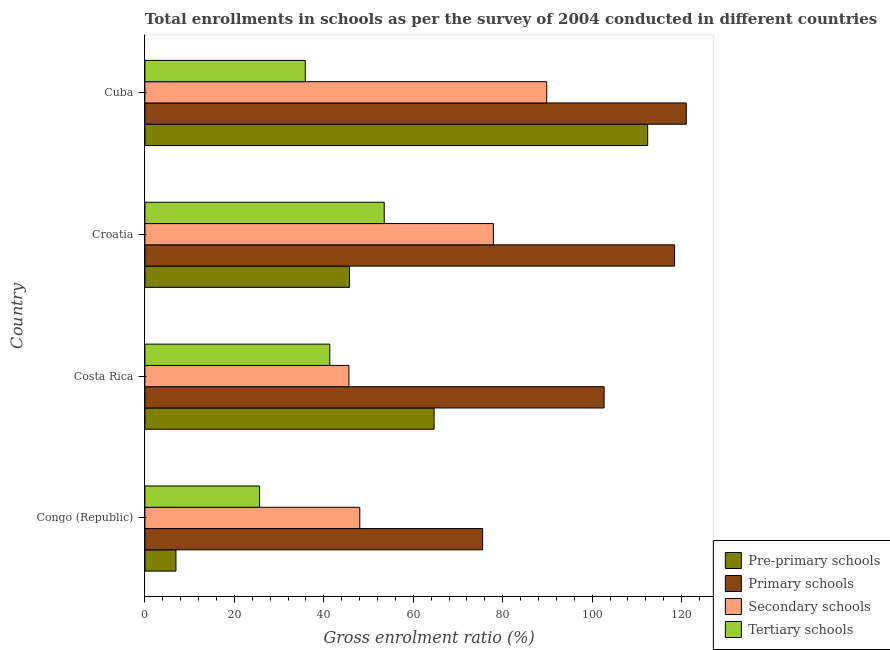Are the number of bars per tick equal to the number of legend labels?
Give a very brief answer. Yes. Are the number of bars on each tick of the Y-axis equal?
Your answer should be very brief. Yes. In how many cases, is the number of bars for a given country not equal to the number of legend labels?
Offer a very short reply. 0. What is the gross enrolment ratio in pre-primary schools in Cuba?
Ensure brevity in your answer.  112.42. Across all countries, what is the maximum gross enrolment ratio in tertiary schools?
Your response must be concise. 53.51. Across all countries, what is the minimum gross enrolment ratio in secondary schools?
Provide a short and direct response. 45.62. In which country was the gross enrolment ratio in tertiary schools maximum?
Ensure brevity in your answer.  Croatia. In which country was the gross enrolment ratio in secondary schools minimum?
Give a very brief answer. Costa Rica. What is the total gross enrolment ratio in tertiary schools in the graph?
Provide a succinct answer. 156.36. What is the difference between the gross enrolment ratio in primary schools in Costa Rica and that in Cuba?
Provide a short and direct response. -18.38. What is the difference between the gross enrolment ratio in pre-primary schools in Croatia and the gross enrolment ratio in primary schools in Cuba?
Give a very brief answer. -75.3. What is the average gross enrolment ratio in primary schools per country?
Your answer should be very brief. 104.42. What is the difference between the gross enrolment ratio in pre-primary schools and gross enrolment ratio in tertiary schools in Congo (Republic)?
Your answer should be compact. -18.7. In how many countries, is the gross enrolment ratio in pre-primary schools greater than 112 %?
Your response must be concise. 1. What is the ratio of the gross enrolment ratio in pre-primary schools in Costa Rica to that in Cuba?
Offer a terse response. 0.57. What is the difference between the highest and the second highest gross enrolment ratio in pre-primary schools?
Provide a succinct answer. 47.75. What is the difference between the highest and the lowest gross enrolment ratio in secondary schools?
Give a very brief answer. 44.23. What does the 4th bar from the top in Cuba represents?
Give a very brief answer. Pre-primary schools. What does the 2nd bar from the bottom in Cuba represents?
Make the answer very short. Primary schools. Is it the case that in every country, the sum of the gross enrolment ratio in pre-primary schools and gross enrolment ratio in primary schools is greater than the gross enrolment ratio in secondary schools?
Offer a terse response. Yes. How many bars are there?
Provide a succinct answer. 16. How many countries are there in the graph?
Provide a succinct answer. 4. Are the values on the major ticks of X-axis written in scientific E-notation?
Make the answer very short. No. Does the graph contain any zero values?
Give a very brief answer. No. Where does the legend appear in the graph?
Provide a succinct answer. Bottom right. How are the legend labels stacked?
Keep it short and to the point. Vertical. What is the title of the graph?
Keep it short and to the point. Total enrollments in schools as per the survey of 2004 conducted in different countries. What is the label or title of the X-axis?
Your response must be concise. Gross enrolment ratio (%). What is the label or title of the Y-axis?
Make the answer very short. Country. What is the Gross enrolment ratio (%) of Pre-primary schools in Congo (Republic)?
Provide a succinct answer. 6.94. What is the Gross enrolment ratio (%) of Primary schools in Congo (Republic)?
Your response must be concise. 75.51. What is the Gross enrolment ratio (%) in Secondary schools in Congo (Republic)?
Your answer should be compact. 48.05. What is the Gross enrolment ratio (%) in Tertiary schools in Congo (Republic)?
Keep it short and to the point. 25.64. What is the Gross enrolment ratio (%) in Pre-primary schools in Costa Rica?
Give a very brief answer. 64.67. What is the Gross enrolment ratio (%) of Primary schools in Costa Rica?
Give a very brief answer. 102.68. What is the Gross enrolment ratio (%) of Secondary schools in Costa Rica?
Provide a succinct answer. 45.62. What is the Gross enrolment ratio (%) of Tertiary schools in Costa Rica?
Offer a very short reply. 41.35. What is the Gross enrolment ratio (%) of Pre-primary schools in Croatia?
Make the answer very short. 45.76. What is the Gross enrolment ratio (%) of Primary schools in Croatia?
Keep it short and to the point. 118.44. What is the Gross enrolment ratio (%) in Secondary schools in Croatia?
Provide a succinct answer. 77.91. What is the Gross enrolment ratio (%) in Tertiary schools in Croatia?
Offer a very short reply. 53.51. What is the Gross enrolment ratio (%) of Pre-primary schools in Cuba?
Make the answer very short. 112.42. What is the Gross enrolment ratio (%) in Primary schools in Cuba?
Ensure brevity in your answer.  121.06. What is the Gross enrolment ratio (%) in Secondary schools in Cuba?
Provide a short and direct response. 89.85. What is the Gross enrolment ratio (%) in Tertiary schools in Cuba?
Give a very brief answer. 35.86. Across all countries, what is the maximum Gross enrolment ratio (%) of Pre-primary schools?
Provide a short and direct response. 112.42. Across all countries, what is the maximum Gross enrolment ratio (%) of Primary schools?
Offer a terse response. 121.06. Across all countries, what is the maximum Gross enrolment ratio (%) of Secondary schools?
Ensure brevity in your answer.  89.85. Across all countries, what is the maximum Gross enrolment ratio (%) in Tertiary schools?
Offer a terse response. 53.51. Across all countries, what is the minimum Gross enrolment ratio (%) of Pre-primary schools?
Offer a terse response. 6.94. Across all countries, what is the minimum Gross enrolment ratio (%) in Primary schools?
Ensure brevity in your answer.  75.51. Across all countries, what is the minimum Gross enrolment ratio (%) in Secondary schools?
Keep it short and to the point. 45.62. Across all countries, what is the minimum Gross enrolment ratio (%) in Tertiary schools?
Your answer should be very brief. 25.64. What is the total Gross enrolment ratio (%) of Pre-primary schools in the graph?
Provide a succinct answer. 229.78. What is the total Gross enrolment ratio (%) of Primary schools in the graph?
Ensure brevity in your answer.  417.69. What is the total Gross enrolment ratio (%) of Secondary schools in the graph?
Your answer should be compact. 261.42. What is the total Gross enrolment ratio (%) in Tertiary schools in the graph?
Your response must be concise. 156.36. What is the difference between the Gross enrolment ratio (%) in Pre-primary schools in Congo (Republic) and that in Costa Rica?
Make the answer very short. -57.73. What is the difference between the Gross enrolment ratio (%) in Primary schools in Congo (Republic) and that in Costa Rica?
Your answer should be compact. -27.17. What is the difference between the Gross enrolment ratio (%) of Secondary schools in Congo (Republic) and that in Costa Rica?
Ensure brevity in your answer.  2.43. What is the difference between the Gross enrolment ratio (%) of Tertiary schools in Congo (Republic) and that in Costa Rica?
Provide a short and direct response. -15.71. What is the difference between the Gross enrolment ratio (%) of Pre-primary schools in Congo (Republic) and that in Croatia?
Your answer should be very brief. -38.82. What is the difference between the Gross enrolment ratio (%) of Primary schools in Congo (Republic) and that in Croatia?
Offer a very short reply. -42.92. What is the difference between the Gross enrolment ratio (%) in Secondary schools in Congo (Republic) and that in Croatia?
Give a very brief answer. -29.86. What is the difference between the Gross enrolment ratio (%) in Tertiary schools in Congo (Republic) and that in Croatia?
Provide a short and direct response. -27.87. What is the difference between the Gross enrolment ratio (%) of Pre-primary schools in Congo (Republic) and that in Cuba?
Give a very brief answer. -105.48. What is the difference between the Gross enrolment ratio (%) in Primary schools in Congo (Republic) and that in Cuba?
Your response must be concise. -45.54. What is the difference between the Gross enrolment ratio (%) in Secondary schools in Congo (Republic) and that in Cuba?
Your response must be concise. -41.8. What is the difference between the Gross enrolment ratio (%) in Tertiary schools in Congo (Republic) and that in Cuba?
Provide a succinct answer. -10.22. What is the difference between the Gross enrolment ratio (%) in Pre-primary schools in Costa Rica and that in Croatia?
Provide a short and direct response. 18.91. What is the difference between the Gross enrolment ratio (%) of Primary schools in Costa Rica and that in Croatia?
Offer a terse response. -15.76. What is the difference between the Gross enrolment ratio (%) of Secondary schools in Costa Rica and that in Croatia?
Keep it short and to the point. -32.3. What is the difference between the Gross enrolment ratio (%) of Tertiary schools in Costa Rica and that in Croatia?
Provide a succinct answer. -12.17. What is the difference between the Gross enrolment ratio (%) in Pre-primary schools in Costa Rica and that in Cuba?
Your answer should be very brief. -47.75. What is the difference between the Gross enrolment ratio (%) of Primary schools in Costa Rica and that in Cuba?
Make the answer very short. -18.38. What is the difference between the Gross enrolment ratio (%) of Secondary schools in Costa Rica and that in Cuba?
Your answer should be very brief. -44.23. What is the difference between the Gross enrolment ratio (%) in Tertiary schools in Costa Rica and that in Cuba?
Your answer should be very brief. 5.48. What is the difference between the Gross enrolment ratio (%) in Pre-primary schools in Croatia and that in Cuba?
Give a very brief answer. -66.66. What is the difference between the Gross enrolment ratio (%) of Primary schools in Croatia and that in Cuba?
Offer a very short reply. -2.62. What is the difference between the Gross enrolment ratio (%) of Secondary schools in Croatia and that in Cuba?
Make the answer very short. -11.94. What is the difference between the Gross enrolment ratio (%) in Tertiary schools in Croatia and that in Cuba?
Your answer should be very brief. 17.65. What is the difference between the Gross enrolment ratio (%) of Pre-primary schools in Congo (Republic) and the Gross enrolment ratio (%) of Primary schools in Costa Rica?
Ensure brevity in your answer.  -95.74. What is the difference between the Gross enrolment ratio (%) in Pre-primary schools in Congo (Republic) and the Gross enrolment ratio (%) in Secondary schools in Costa Rica?
Make the answer very short. -38.68. What is the difference between the Gross enrolment ratio (%) of Pre-primary schools in Congo (Republic) and the Gross enrolment ratio (%) of Tertiary schools in Costa Rica?
Keep it short and to the point. -34.41. What is the difference between the Gross enrolment ratio (%) in Primary schools in Congo (Republic) and the Gross enrolment ratio (%) in Secondary schools in Costa Rica?
Offer a terse response. 29.9. What is the difference between the Gross enrolment ratio (%) in Primary schools in Congo (Republic) and the Gross enrolment ratio (%) in Tertiary schools in Costa Rica?
Provide a succinct answer. 34.17. What is the difference between the Gross enrolment ratio (%) of Secondary schools in Congo (Republic) and the Gross enrolment ratio (%) of Tertiary schools in Costa Rica?
Offer a terse response. 6.7. What is the difference between the Gross enrolment ratio (%) of Pre-primary schools in Congo (Republic) and the Gross enrolment ratio (%) of Primary schools in Croatia?
Provide a succinct answer. -111.5. What is the difference between the Gross enrolment ratio (%) of Pre-primary schools in Congo (Republic) and the Gross enrolment ratio (%) of Secondary schools in Croatia?
Your answer should be compact. -70.97. What is the difference between the Gross enrolment ratio (%) in Pre-primary schools in Congo (Republic) and the Gross enrolment ratio (%) in Tertiary schools in Croatia?
Give a very brief answer. -46.57. What is the difference between the Gross enrolment ratio (%) of Primary schools in Congo (Republic) and the Gross enrolment ratio (%) of Secondary schools in Croatia?
Provide a short and direct response. -2.4. What is the difference between the Gross enrolment ratio (%) in Primary schools in Congo (Republic) and the Gross enrolment ratio (%) in Tertiary schools in Croatia?
Ensure brevity in your answer.  22. What is the difference between the Gross enrolment ratio (%) in Secondary schools in Congo (Republic) and the Gross enrolment ratio (%) in Tertiary schools in Croatia?
Offer a very short reply. -5.46. What is the difference between the Gross enrolment ratio (%) in Pre-primary schools in Congo (Republic) and the Gross enrolment ratio (%) in Primary schools in Cuba?
Make the answer very short. -114.12. What is the difference between the Gross enrolment ratio (%) of Pre-primary schools in Congo (Republic) and the Gross enrolment ratio (%) of Secondary schools in Cuba?
Keep it short and to the point. -82.91. What is the difference between the Gross enrolment ratio (%) in Pre-primary schools in Congo (Republic) and the Gross enrolment ratio (%) in Tertiary schools in Cuba?
Provide a succinct answer. -28.93. What is the difference between the Gross enrolment ratio (%) in Primary schools in Congo (Republic) and the Gross enrolment ratio (%) in Secondary schools in Cuba?
Offer a terse response. -14.33. What is the difference between the Gross enrolment ratio (%) in Primary schools in Congo (Republic) and the Gross enrolment ratio (%) in Tertiary schools in Cuba?
Your answer should be compact. 39.65. What is the difference between the Gross enrolment ratio (%) in Secondary schools in Congo (Republic) and the Gross enrolment ratio (%) in Tertiary schools in Cuba?
Keep it short and to the point. 12.18. What is the difference between the Gross enrolment ratio (%) in Pre-primary schools in Costa Rica and the Gross enrolment ratio (%) in Primary schools in Croatia?
Ensure brevity in your answer.  -53.77. What is the difference between the Gross enrolment ratio (%) in Pre-primary schools in Costa Rica and the Gross enrolment ratio (%) in Secondary schools in Croatia?
Ensure brevity in your answer.  -13.25. What is the difference between the Gross enrolment ratio (%) of Pre-primary schools in Costa Rica and the Gross enrolment ratio (%) of Tertiary schools in Croatia?
Offer a terse response. 11.15. What is the difference between the Gross enrolment ratio (%) in Primary schools in Costa Rica and the Gross enrolment ratio (%) in Secondary schools in Croatia?
Provide a short and direct response. 24.77. What is the difference between the Gross enrolment ratio (%) in Primary schools in Costa Rica and the Gross enrolment ratio (%) in Tertiary schools in Croatia?
Your answer should be very brief. 49.17. What is the difference between the Gross enrolment ratio (%) of Secondary schools in Costa Rica and the Gross enrolment ratio (%) of Tertiary schools in Croatia?
Give a very brief answer. -7.9. What is the difference between the Gross enrolment ratio (%) in Pre-primary schools in Costa Rica and the Gross enrolment ratio (%) in Primary schools in Cuba?
Provide a short and direct response. -56.39. What is the difference between the Gross enrolment ratio (%) of Pre-primary schools in Costa Rica and the Gross enrolment ratio (%) of Secondary schools in Cuba?
Provide a succinct answer. -25.18. What is the difference between the Gross enrolment ratio (%) of Pre-primary schools in Costa Rica and the Gross enrolment ratio (%) of Tertiary schools in Cuba?
Give a very brief answer. 28.8. What is the difference between the Gross enrolment ratio (%) in Primary schools in Costa Rica and the Gross enrolment ratio (%) in Secondary schools in Cuba?
Offer a terse response. 12.83. What is the difference between the Gross enrolment ratio (%) in Primary schools in Costa Rica and the Gross enrolment ratio (%) in Tertiary schools in Cuba?
Keep it short and to the point. 66.82. What is the difference between the Gross enrolment ratio (%) in Secondary schools in Costa Rica and the Gross enrolment ratio (%) in Tertiary schools in Cuba?
Provide a short and direct response. 9.75. What is the difference between the Gross enrolment ratio (%) in Pre-primary schools in Croatia and the Gross enrolment ratio (%) in Primary schools in Cuba?
Keep it short and to the point. -75.3. What is the difference between the Gross enrolment ratio (%) of Pre-primary schools in Croatia and the Gross enrolment ratio (%) of Secondary schools in Cuba?
Provide a short and direct response. -44.09. What is the difference between the Gross enrolment ratio (%) in Pre-primary schools in Croatia and the Gross enrolment ratio (%) in Tertiary schools in Cuba?
Offer a terse response. 9.9. What is the difference between the Gross enrolment ratio (%) in Primary schools in Croatia and the Gross enrolment ratio (%) in Secondary schools in Cuba?
Your answer should be compact. 28.59. What is the difference between the Gross enrolment ratio (%) in Primary schools in Croatia and the Gross enrolment ratio (%) in Tertiary schools in Cuba?
Keep it short and to the point. 82.57. What is the difference between the Gross enrolment ratio (%) of Secondary schools in Croatia and the Gross enrolment ratio (%) of Tertiary schools in Cuba?
Provide a succinct answer. 42.05. What is the average Gross enrolment ratio (%) of Pre-primary schools per country?
Provide a short and direct response. 57.45. What is the average Gross enrolment ratio (%) in Primary schools per country?
Provide a short and direct response. 104.42. What is the average Gross enrolment ratio (%) in Secondary schools per country?
Offer a very short reply. 65.36. What is the average Gross enrolment ratio (%) in Tertiary schools per country?
Ensure brevity in your answer.  39.09. What is the difference between the Gross enrolment ratio (%) in Pre-primary schools and Gross enrolment ratio (%) in Primary schools in Congo (Republic)?
Offer a terse response. -68.57. What is the difference between the Gross enrolment ratio (%) in Pre-primary schools and Gross enrolment ratio (%) in Secondary schools in Congo (Republic)?
Make the answer very short. -41.11. What is the difference between the Gross enrolment ratio (%) in Pre-primary schools and Gross enrolment ratio (%) in Tertiary schools in Congo (Republic)?
Offer a very short reply. -18.7. What is the difference between the Gross enrolment ratio (%) of Primary schools and Gross enrolment ratio (%) of Secondary schools in Congo (Republic)?
Provide a succinct answer. 27.47. What is the difference between the Gross enrolment ratio (%) in Primary schools and Gross enrolment ratio (%) in Tertiary schools in Congo (Republic)?
Your response must be concise. 49.87. What is the difference between the Gross enrolment ratio (%) in Secondary schools and Gross enrolment ratio (%) in Tertiary schools in Congo (Republic)?
Make the answer very short. 22.41. What is the difference between the Gross enrolment ratio (%) in Pre-primary schools and Gross enrolment ratio (%) in Primary schools in Costa Rica?
Provide a short and direct response. -38.01. What is the difference between the Gross enrolment ratio (%) of Pre-primary schools and Gross enrolment ratio (%) of Secondary schools in Costa Rica?
Offer a terse response. 19.05. What is the difference between the Gross enrolment ratio (%) in Pre-primary schools and Gross enrolment ratio (%) in Tertiary schools in Costa Rica?
Ensure brevity in your answer.  23.32. What is the difference between the Gross enrolment ratio (%) of Primary schools and Gross enrolment ratio (%) of Secondary schools in Costa Rica?
Provide a short and direct response. 57.06. What is the difference between the Gross enrolment ratio (%) of Primary schools and Gross enrolment ratio (%) of Tertiary schools in Costa Rica?
Provide a succinct answer. 61.33. What is the difference between the Gross enrolment ratio (%) in Secondary schools and Gross enrolment ratio (%) in Tertiary schools in Costa Rica?
Ensure brevity in your answer.  4.27. What is the difference between the Gross enrolment ratio (%) of Pre-primary schools and Gross enrolment ratio (%) of Primary schools in Croatia?
Make the answer very short. -72.68. What is the difference between the Gross enrolment ratio (%) of Pre-primary schools and Gross enrolment ratio (%) of Secondary schools in Croatia?
Your answer should be compact. -32.15. What is the difference between the Gross enrolment ratio (%) of Pre-primary schools and Gross enrolment ratio (%) of Tertiary schools in Croatia?
Your answer should be compact. -7.75. What is the difference between the Gross enrolment ratio (%) of Primary schools and Gross enrolment ratio (%) of Secondary schools in Croatia?
Your answer should be compact. 40.53. What is the difference between the Gross enrolment ratio (%) in Primary schools and Gross enrolment ratio (%) in Tertiary schools in Croatia?
Your answer should be compact. 64.93. What is the difference between the Gross enrolment ratio (%) in Secondary schools and Gross enrolment ratio (%) in Tertiary schools in Croatia?
Your answer should be compact. 24.4. What is the difference between the Gross enrolment ratio (%) in Pre-primary schools and Gross enrolment ratio (%) in Primary schools in Cuba?
Give a very brief answer. -8.64. What is the difference between the Gross enrolment ratio (%) of Pre-primary schools and Gross enrolment ratio (%) of Secondary schools in Cuba?
Provide a short and direct response. 22.57. What is the difference between the Gross enrolment ratio (%) of Pre-primary schools and Gross enrolment ratio (%) of Tertiary schools in Cuba?
Give a very brief answer. 76.56. What is the difference between the Gross enrolment ratio (%) of Primary schools and Gross enrolment ratio (%) of Secondary schools in Cuba?
Provide a short and direct response. 31.21. What is the difference between the Gross enrolment ratio (%) of Primary schools and Gross enrolment ratio (%) of Tertiary schools in Cuba?
Your response must be concise. 85.19. What is the difference between the Gross enrolment ratio (%) in Secondary schools and Gross enrolment ratio (%) in Tertiary schools in Cuba?
Provide a short and direct response. 53.98. What is the ratio of the Gross enrolment ratio (%) of Pre-primary schools in Congo (Republic) to that in Costa Rica?
Keep it short and to the point. 0.11. What is the ratio of the Gross enrolment ratio (%) in Primary schools in Congo (Republic) to that in Costa Rica?
Make the answer very short. 0.74. What is the ratio of the Gross enrolment ratio (%) of Secondary schools in Congo (Republic) to that in Costa Rica?
Offer a very short reply. 1.05. What is the ratio of the Gross enrolment ratio (%) in Tertiary schools in Congo (Republic) to that in Costa Rica?
Keep it short and to the point. 0.62. What is the ratio of the Gross enrolment ratio (%) in Pre-primary schools in Congo (Republic) to that in Croatia?
Provide a short and direct response. 0.15. What is the ratio of the Gross enrolment ratio (%) in Primary schools in Congo (Republic) to that in Croatia?
Provide a short and direct response. 0.64. What is the ratio of the Gross enrolment ratio (%) in Secondary schools in Congo (Republic) to that in Croatia?
Your answer should be compact. 0.62. What is the ratio of the Gross enrolment ratio (%) in Tertiary schools in Congo (Republic) to that in Croatia?
Your answer should be very brief. 0.48. What is the ratio of the Gross enrolment ratio (%) in Pre-primary schools in Congo (Republic) to that in Cuba?
Provide a succinct answer. 0.06. What is the ratio of the Gross enrolment ratio (%) in Primary schools in Congo (Republic) to that in Cuba?
Offer a very short reply. 0.62. What is the ratio of the Gross enrolment ratio (%) of Secondary schools in Congo (Republic) to that in Cuba?
Offer a very short reply. 0.53. What is the ratio of the Gross enrolment ratio (%) of Tertiary schools in Congo (Republic) to that in Cuba?
Offer a terse response. 0.71. What is the ratio of the Gross enrolment ratio (%) of Pre-primary schools in Costa Rica to that in Croatia?
Offer a very short reply. 1.41. What is the ratio of the Gross enrolment ratio (%) in Primary schools in Costa Rica to that in Croatia?
Make the answer very short. 0.87. What is the ratio of the Gross enrolment ratio (%) in Secondary schools in Costa Rica to that in Croatia?
Provide a succinct answer. 0.59. What is the ratio of the Gross enrolment ratio (%) in Tertiary schools in Costa Rica to that in Croatia?
Provide a succinct answer. 0.77. What is the ratio of the Gross enrolment ratio (%) in Pre-primary schools in Costa Rica to that in Cuba?
Provide a short and direct response. 0.58. What is the ratio of the Gross enrolment ratio (%) of Primary schools in Costa Rica to that in Cuba?
Your answer should be compact. 0.85. What is the ratio of the Gross enrolment ratio (%) of Secondary schools in Costa Rica to that in Cuba?
Offer a terse response. 0.51. What is the ratio of the Gross enrolment ratio (%) of Tertiary schools in Costa Rica to that in Cuba?
Offer a terse response. 1.15. What is the ratio of the Gross enrolment ratio (%) of Pre-primary schools in Croatia to that in Cuba?
Offer a terse response. 0.41. What is the ratio of the Gross enrolment ratio (%) in Primary schools in Croatia to that in Cuba?
Provide a succinct answer. 0.98. What is the ratio of the Gross enrolment ratio (%) in Secondary schools in Croatia to that in Cuba?
Keep it short and to the point. 0.87. What is the ratio of the Gross enrolment ratio (%) of Tertiary schools in Croatia to that in Cuba?
Keep it short and to the point. 1.49. What is the difference between the highest and the second highest Gross enrolment ratio (%) of Pre-primary schools?
Ensure brevity in your answer.  47.75. What is the difference between the highest and the second highest Gross enrolment ratio (%) of Primary schools?
Your response must be concise. 2.62. What is the difference between the highest and the second highest Gross enrolment ratio (%) in Secondary schools?
Make the answer very short. 11.94. What is the difference between the highest and the second highest Gross enrolment ratio (%) in Tertiary schools?
Provide a succinct answer. 12.17. What is the difference between the highest and the lowest Gross enrolment ratio (%) of Pre-primary schools?
Provide a short and direct response. 105.48. What is the difference between the highest and the lowest Gross enrolment ratio (%) of Primary schools?
Offer a very short reply. 45.54. What is the difference between the highest and the lowest Gross enrolment ratio (%) in Secondary schools?
Ensure brevity in your answer.  44.23. What is the difference between the highest and the lowest Gross enrolment ratio (%) of Tertiary schools?
Keep it short and to the point. 27.87. 